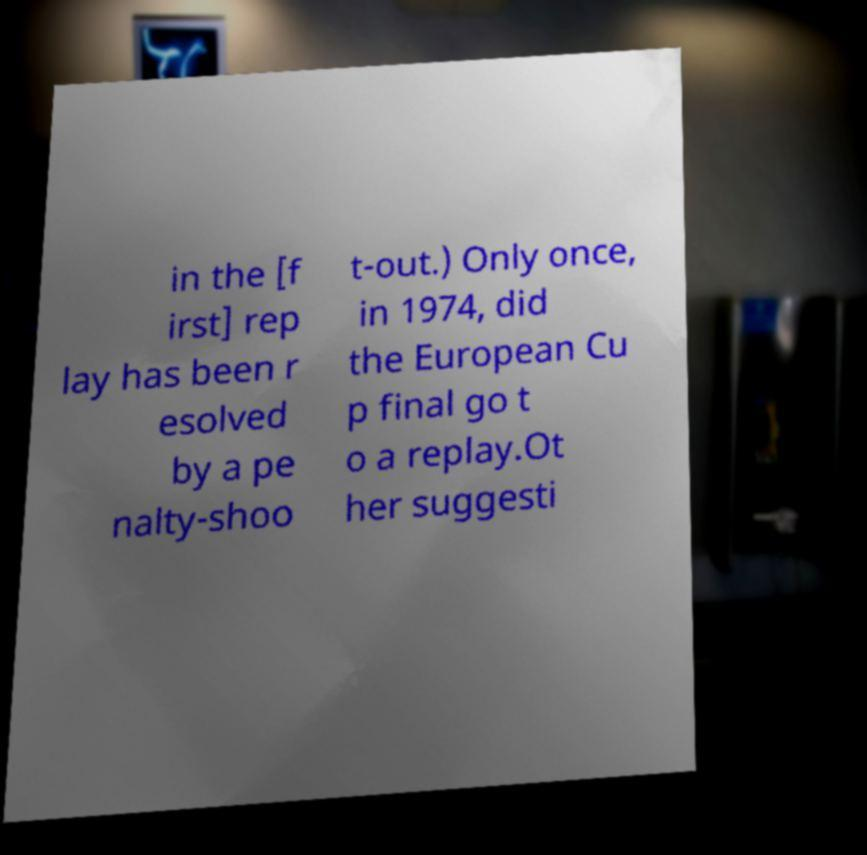Can you read and provide the text displayed in the image?This photo seems to have some interesting text. Can you extract and type it out for me? in the [f irst] rep lay has been r esolved by a pe nalty-shoo t-out.) Only once, in 1974, did the European Cu p final go t o a replay.Ot her suggesti 